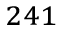<formula> <loc_0><loc_0><loc_500><loc_500>^ { 2 4 1 }</formula> 